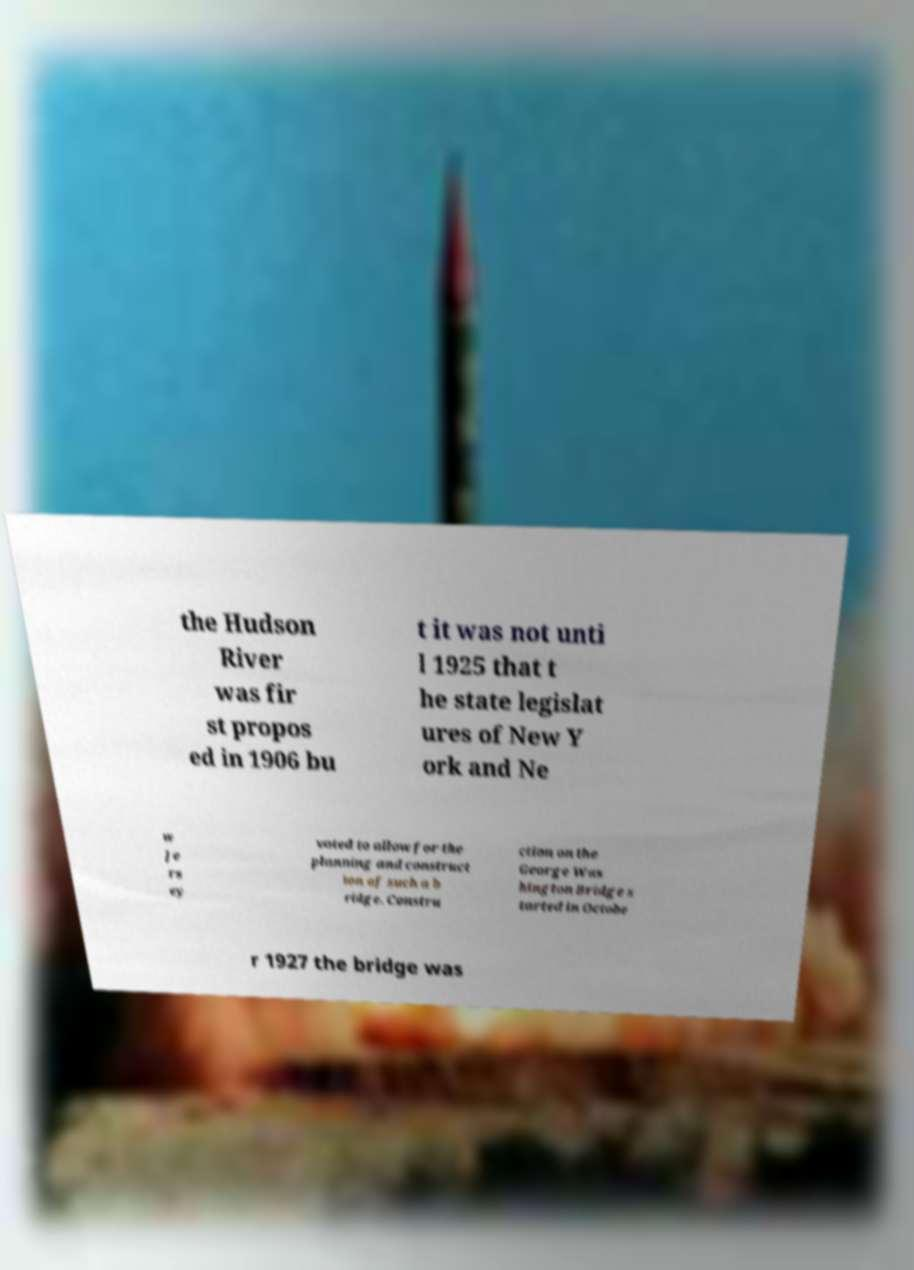Please identify and transcribe the text found in this image. the Hudson River was fir st propos ed in 1906 bu t it was not unti l 1925 that t he state legislat ures of New Y ork and Ne w Je rs ey voted to allow for the planning and construct ion of such a b ridge. Constru ction on the George Was hington Bridge s tarted in Octobe r 1927 the bridge was 